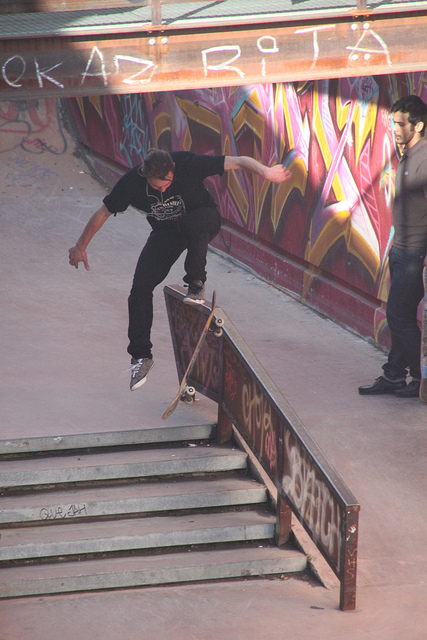Extract all visible text content from this image. RiTA Rita 